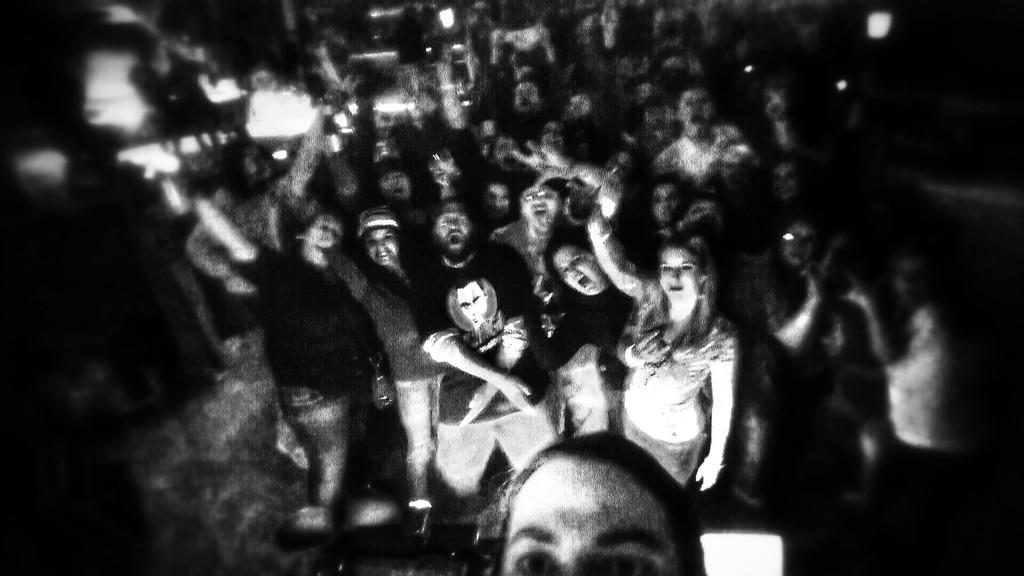Can you describe this image briefly? In this image we can see people and there are lights. 